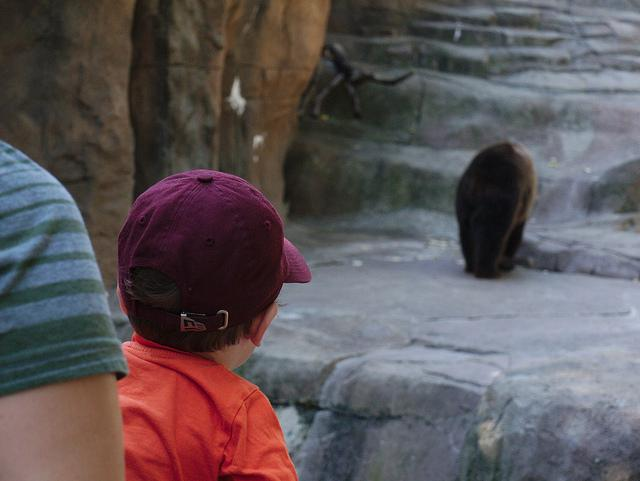Where is the boy visiting?

Choices:
A) zoo
B) jungle
C) yard
D) school zoo 